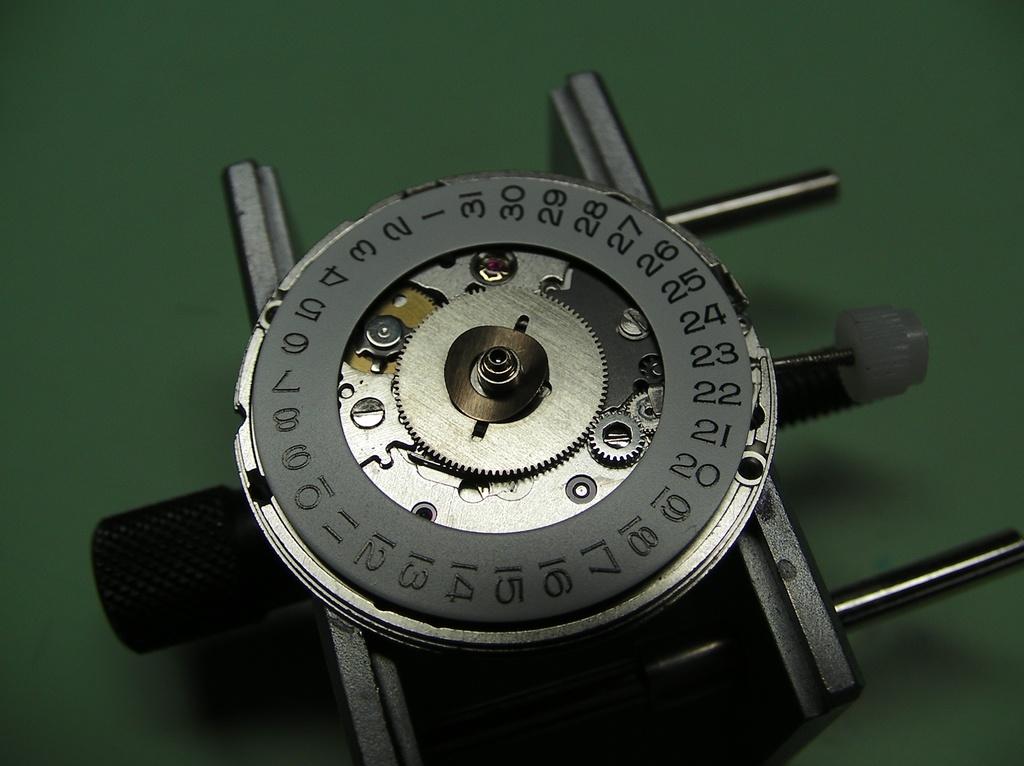What is the highest number on this device?
Your response must be concise. 31. What is the lowest number on the device?
Give a very brief answer. 1. 